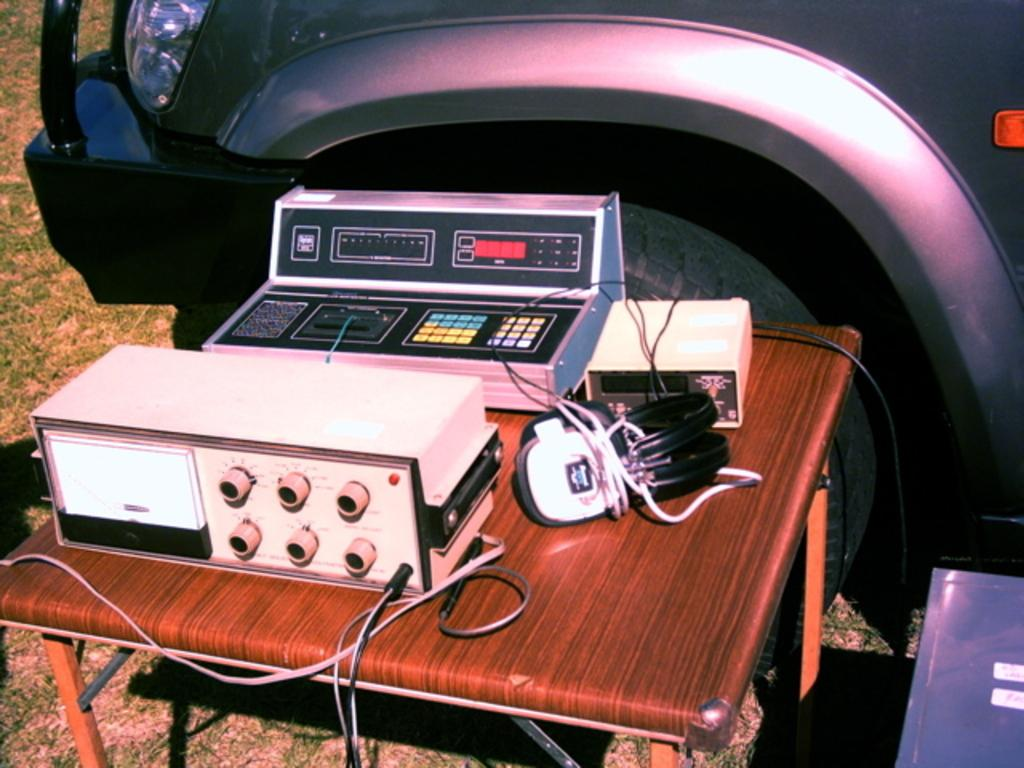What type of vegetation is at the bottom of the image? There is grass at the bottom of the image. What can be seen on the table in the foreground? There is a table with machines and objects on it in the foreground. What is located in the background of the image? There is a vehicle in the background of the image. How many oranges are on the scarecrow in the image? There is no scarecrow or oranges present in the image. Can you describe the ants crawling on the grass in the image? There are no ants visible in the image; it only shows grass, a table with machines and objects, and a vehicle in the background. 